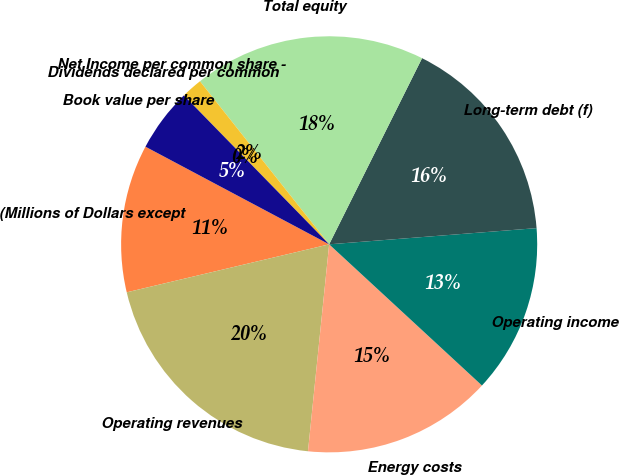Convert chart. <chart><loc_0><loc_0><loc_500><loc_500><pie_chart><fcel>(Millions of Dollars except<fcel>Operating revenues<fcel>Energy costs<fcel>Operating income<fcel>Long-term debt (f)<fcel>Total equity<fcel>Net Income per common share -<fcel>Dividends declared per common<fcel>Book value per share<nl><fcel>11.48%<fcel>19.67%<fcel>14.75%<fcel>13.11%<fcel>16.39%<fcel>18.03%<fcel>1.64%<fcel>0.0%<fcel>4.92%<nl></chart> 